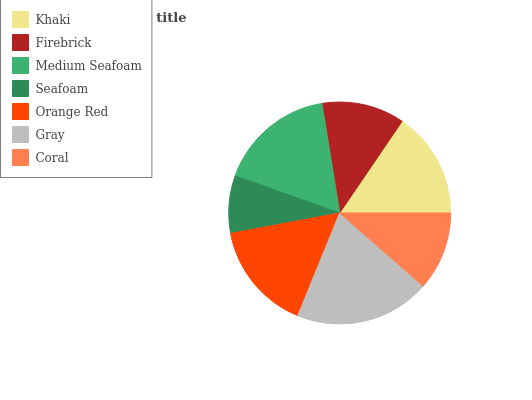Is Seafoam the minimum?
Answer yes or no. Yes. Is Gray the maximum?
Answer yes or no. Yes. Is Firebrick the minimum?
Answer yes or no. No. Is Firebrick the maximum?
Answer yes or no. No. Is Khaki greater than Firebrick?
Answer yes or no. Yes. Is Firebrick less than Khaki?
Answer yes or no. Yes. Is Firebrick greater than Khaki?
Answer yes or no. No. Is Khaki less than Firebrick?
Answer yes or no. No. Is Khaki the high median?
Answer yes or no. Yes. Is Khaki the low median?
Answer yes or no. Yes. Is Seafoam the high median?
Answer yes or no. No. Is Orange Red the low median?
Answer yes or no. No. 